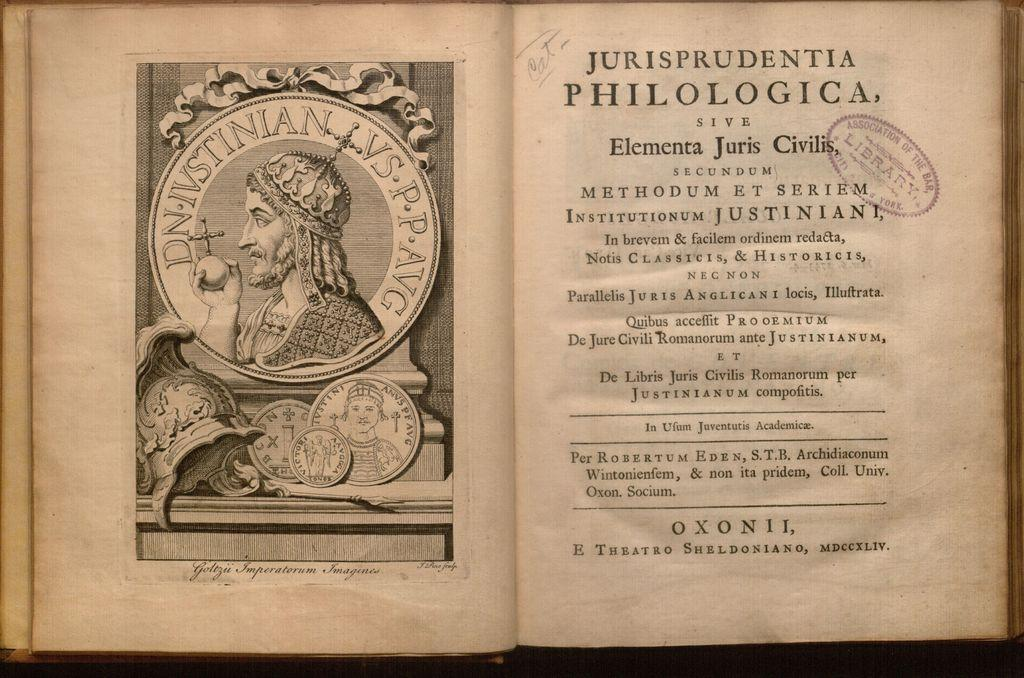<image>
Share a concise interpretation of the image provided. An old book in Latin is open to the title page which says Jurisprudentia. 